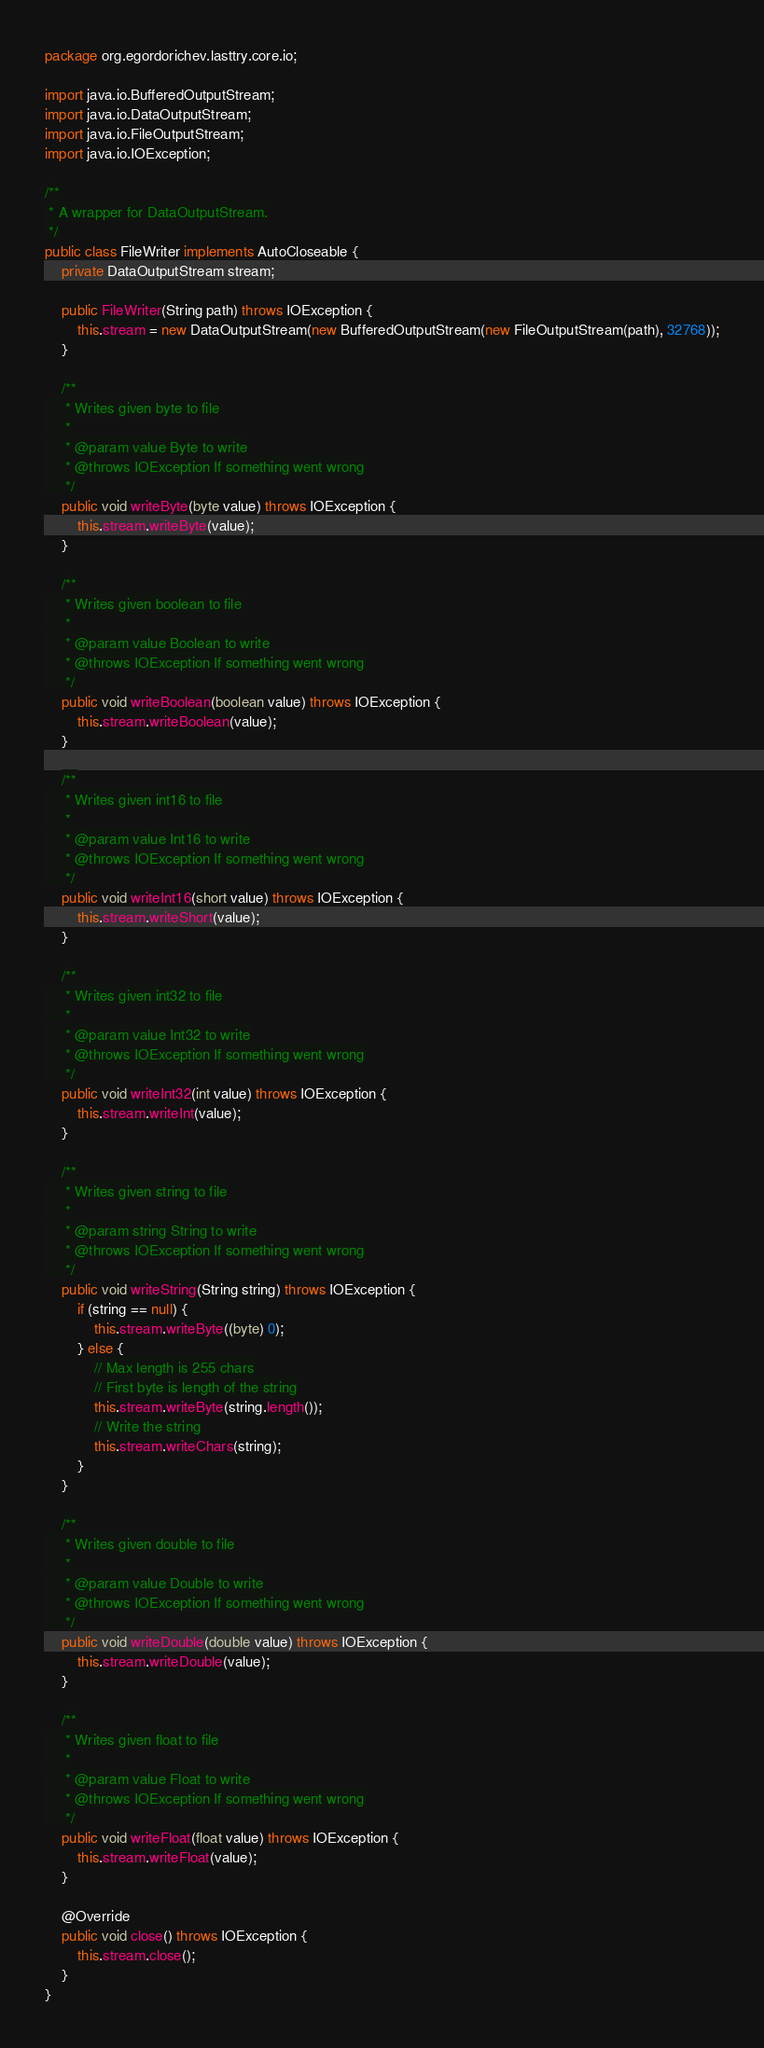Convert code to text. <code><loc_0><loc_0><loc_500><loc_500><_Java_>package org.egordorichev.lasttry.core.io;

import java.io.BufferedOutputStream;
import java.io.DataOutputStream;
import java.io.FileOutputStream;
import java.io.IOException;

/**
 * A wrapper for DataOutputStream.
 */
public class FileWriter implements AutoCloseable {
	private DataOutputStream stream;

	public FileWriter(String path) throws IOException {
		this.stream = new DataOutputStream(new BufferedOutputStream(new FileOutputStream(path), 32768));
	}

	/**
	 * Writes given byte to file
	 *
	 * @param value Byte to write
	 * @throws IOException If something went wrong
	 */
	public void writeByte(byte value) throws IOException {
		this.stream.writeByte(value);
	}

	/**
	 * Writes given boolean to file
	 *
	 * @param value Boolean to write
	 * @throws IOException If something went wrong
	 */
	public void writeBoolean(boolean value) throws IOException {
		this.stream.writeBoolean(value);
	}

	/**
	 * Writes given int16 to file
	 *
	 * @param value Int16 to write
	 * @throws IOException If something went wrong
	 */
	public void writeInt16(short value) throws IOException {
		this.stream.writeShort(value);
	}

	/**
	 * Writes given int32 to file
	 *
	 * @param value Int32 to write
	 * @throws IOException If something went wrong
	 */
	public void writeInt32(int value) throws IOException {
		this.stream.writeInt(value);
	}

	/**
	 * Writes given string to file
	 *
	 * @param string String to write
	 * @throws IOException If something went wrong
	 */
	public void writeString(String string) throws IOException {
		if (string == null) {
			this.stream.writeByte((byte) 0);
		} else {
			// Max length is 255 chars
			// First byte is length of the string
			this.stream.writeByte(string.length());
			// Write the string
			this.stream.writeChars(string);
		}
	}

	/**
	 * Writes given double to file
	 *
	 * @param value Double to write
	 * @throws IOException If something went wrong
	 */
	public void writeDouble(double value) throws IOException {
		this.stream.writeDouble(value);
	}

	/**
	 * Writes given float to file
	 *
	 * @param value Float to write
	 * @throws IOException If something went wrong
	 */
	public void writeFloat(float value) throws IOException {
		this.stream.writeFloat(value);
	}

	@Override
	public void close() throws IOException {
		this.stream.close();
	}
}</code> 